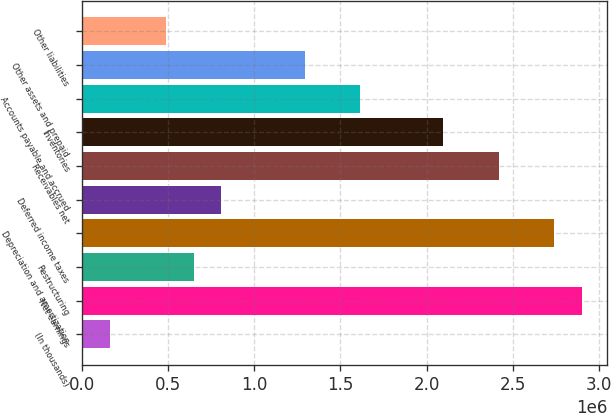Convert chart to OTSL. <chart><loc_0><loc_0><loc_500><loc_500><bar_chart><fcel>(In thousands)<fcel>Net earnings<fcel>Restructuring<fcel>Depreciation and amortization<fcel>Deferred income taxes<fcel>Receivables net<fcel>Inventories<fcel>Accounts payable and accrued<fcel>Other assets and prepaid<fcel>Other liabilities<nl><fcel>163076<fcel>2.90274e+06<fcel>646546<fcel>2.74158e+06<fcel>807702<fcel>2.41927e+06<fcel>2.09695e+06<fcel>1.61348e+06<fcel>1.29117e+06<fcel>485389<nl></chart> 